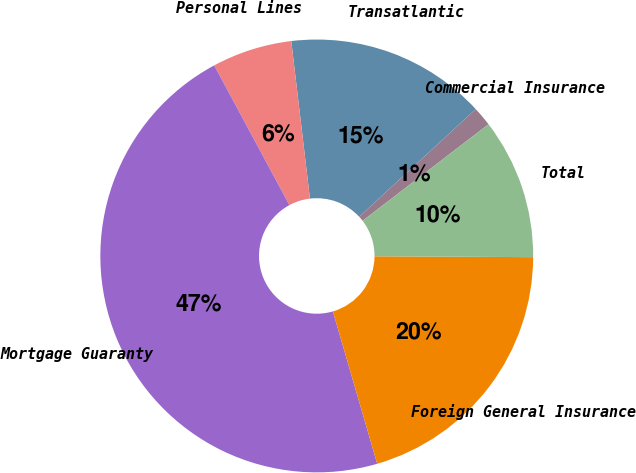Convert chart to OTSL. <chart><loc_0><loc_0><loc_500><loc_500><pie_chart><fcel>Commercial Insurance<fcel>Transatlantic<fcel>Personal Lines<fcel>Mortgage Guaranty<fcel>Foreign General Insurance<fcel>Total<nl><fcel>1.46%<fcel>15.01%<fcel>5.98%<fcel>46.65%<fcel>20.41%<fcel>10.5%<nl></chart> 